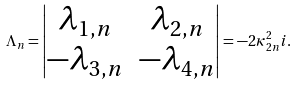Convert formula to latex. <formula><loc_0><loc_0><loc_500><loc_500>\Lambda _ { n } = \begin{vmatrix} \lambda _ { 1 , n } & \lambda _ { 2 , n } \\ - \lambda _ { 3 , n } & - \lambda _ { 4 , n } \\ \end{vmatrix} = - 2 \kappa ^ { 2 } _ { 2 n } i .</formula> 